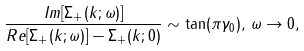<formula> <loc_0><loc_0><loc_500><loc_500>\frac { I m [ \Sigma _ { + } ( k ; \omega ) ] } { R e [ \Sigma _ { + } ( k ; \omega ) ] - \Sigma _ { + } ( k ; 0 ) } \sim \tan ( \pi \gamma _ { 0 } ) , \, \omega \to 0 ,</formula> 